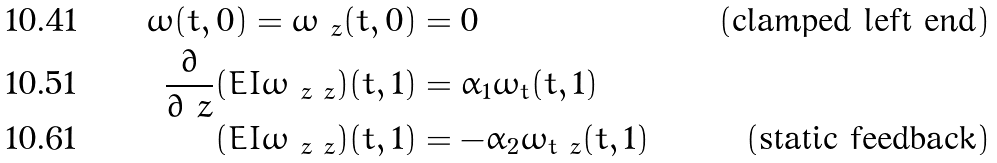<formula> <loc_0><loc_0><loc_500><loc_500>\omega ( t , 0 ) = \omega _ { \ z } ( t , 0 ) & = 0 & ( \text {clamped left end} ) \\ \frac { \partial } { \partial \ z } ( E I \omega _ { \ z \ z } ) ( t , 1 ) & = \alpha _ { 1 } \omega _ { t } ( t , 1 ) \\ ( E I \omega _ { \ z \ z } ) ( t , 1 ) & = - \alpha _ { 2 } \omega _ { t \ z } ( t , 1 ) & ( \text {static feedback} )</formula> 